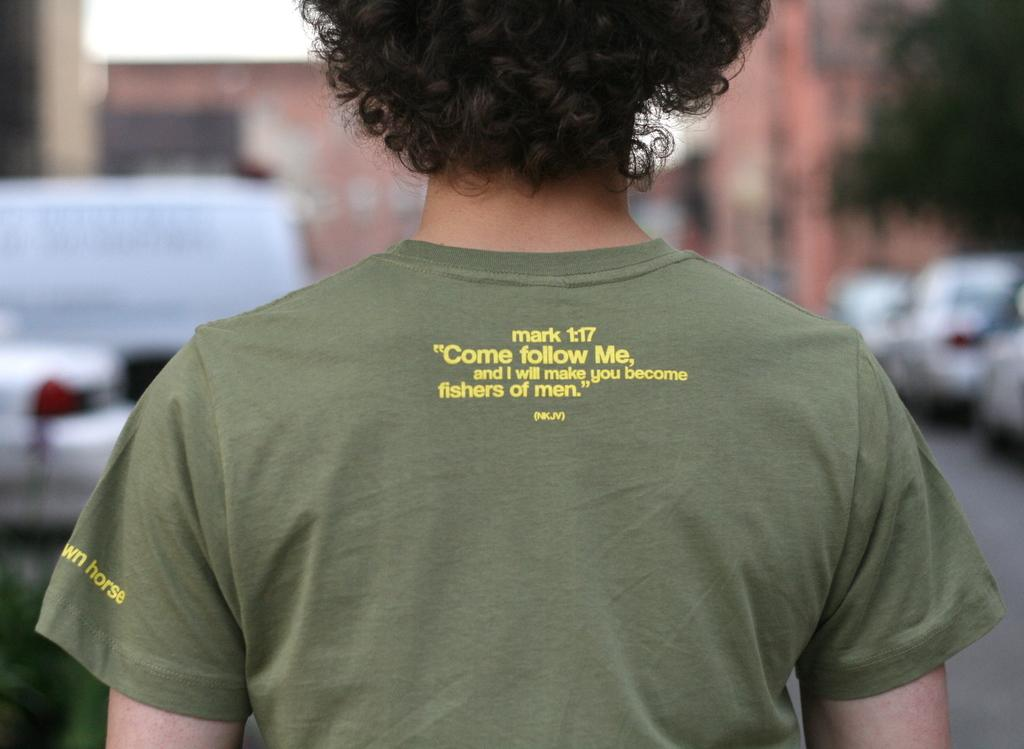What is present in the image? There is a person in the image. Can you describe the person's position or orientation? The person is facing away from the camera. Is there any text visible in the image? Yes, there is text visible on the person's t-shirt. How many pigs can be seen playing with a cracker in the image? There are no pigs or crackers present in the image; it features a person facing away from the camera with text on their t-shirt. 